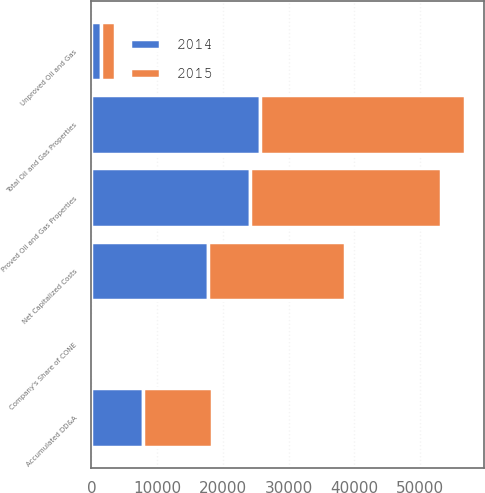<chart> <loc_0><loc_0><loc_500><loc_500><stacked_bar_chart><ecel><fcel>Unproved Oil and Gas<fcel>Proved Oil and Gas Properties<fcel>Total Oil and Gas Properties<fcel>Accumulated DD&A<fcel>Net Capitalized Costs<fcel>Company's Share of CONE<nl><fcel>2015<fcel>2151<fcel>29069<fcel>31220<fcel>10439<fcel>20781<fcel>433<nl><fcel>2014<fcel>1487<fcel>24112<fcel>25599<fcel>7820<fcel>17779<fcel>290<nl></chart> 